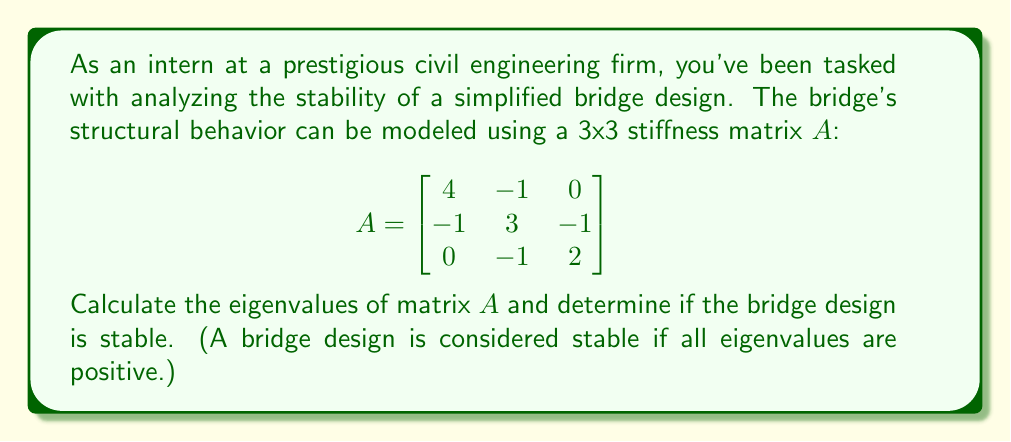Solve this math problem. To analyze the stability of the bridge design, we need to find the eigenvalues of the stiffness matrix $A$. The eigenvalues represent the natural frequencies of the structure, and positive eigenvalues indicate a stable design.

Step 1: Set up the characteristic equation
The characteristic equation is given by $\det(A - \lambda I) = 0$, where $\lambda$ represents the eigenvalues and $I$ is the 3x3 identity matrix.

$$\det\begin{pmatrix}
4-\lambda & -1 & 0 \\
-1 & 3-\lambda & -1 \\
0 & -1 & 2-\lambda
\end{pmatrix} = 0$$

Step 2: Expand the determinant
$$(4-\lambda)[(3-\lambda)(2-\lambda) - 1] - (-1)[(-1)(2-\lambda) - 0] = 0$$
$$(4-\lambda)[(6-5\lambda+\lambda^2) - 1] + (2-\lambda) = 0$$
$$(4-\lambda)(5-5\lambda+\lambda^2) + (2-\lambda) = 0$$

Step 3: Simplify the equation
$$20-20\lambda+4\lambda^2-5\lambda+5\lambda^2-\lambda^3+2-\lambda = 0$$
$$-\lambda^3+9\lambda^2-26\lambda+22 = 0$$

Step 4: Solve the cubic equation
This cubic equation can be solved using various methods, such as the cubic formula or numerical methods. In this case, the eigenvalues are:

$\lambda_1 \approx 1.2649$
$\lambda_2 \approx 2.0000$
$\lambda_3 \approx 5.7351$

Step 5: Analyze the stability
Since all eigenvalues are positive, the bridge design is stable.
Answer: The eigenvalues of the stiffness matrix $A$ are approximately $\lambda_1 \approx 1.2649$, $\lambda_2 \approx 2.0000$, and $\lambda_3 \approx 5.7351$. As all eigenvalues are positive, the bridge design is stable. 